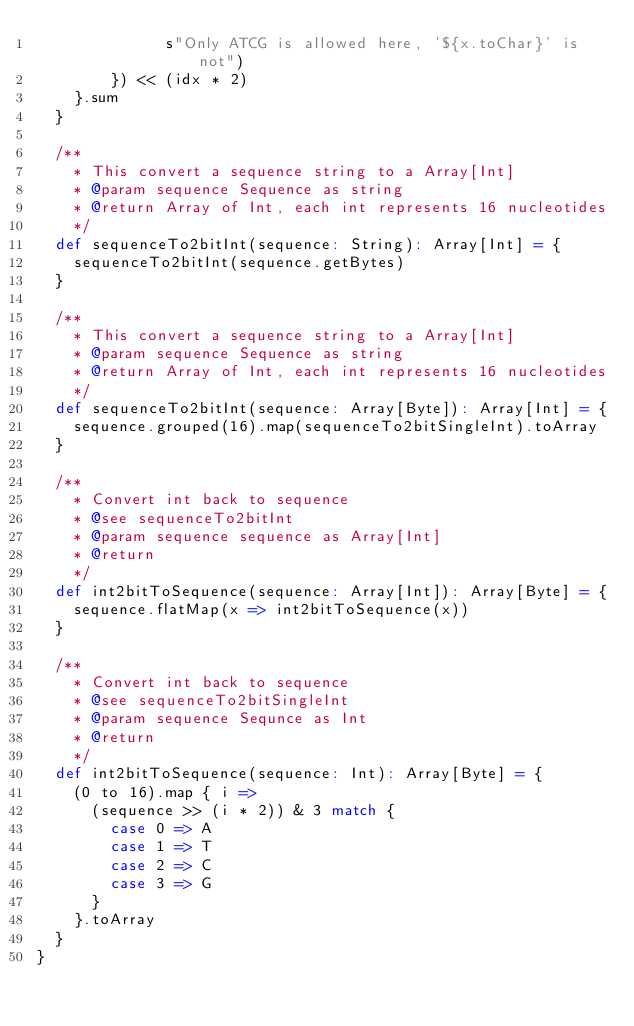Convert code to text. <code><loc_0><loc_0><loc_500><loc_500><_Scala_>              s"Only ATCG is allowed here, '${x.toChar}' is not")
        }) << (idx * 2)
    }.sum
  }

  /**
    * This convert a sequence string to a Array[Int]
    * @param sequence Sequence as string
    * @return Array of Int, each int represents 16 nucleotides
    */
  def sequenceTo2bitInt(sequence: String): Array[Int] = {
    sequenceTo2bitInt(sequence.getBytes)
  }

  /**
    * This convert a sequence string to a Array[Int]
    * @param sequence Sequence as string
    * @return Array of Int, each int represents 16 nucleotides
    */
  def sequenceTo2bitInt(sequence: Array[Byte]): Array[Int] = {
    sequence.grouped(16).map(sequenceTo2bitSingleInt).toArray
  }

  /**
    * Convert int back to sequence
    * @see sequenceTo2bitInt
    * @param sequence sequence as Array[Int]
    * @return
    */
  def int2bitToSequence(sequence: Array[Int]): Array[Byte] = {
    sequence.flatMap(x => int2bitToSequence(x))
  }

  /**
    * Convert int back to sequence
    * @see sequenceTo2bitSingleInt
    * @param sequence Sequnce as Int
    * @return
    */
  def int2bitToSequence(sequence: Int): Array[Byte] = {
    (0 to 16).map { i =>
      (sequence >> (i * 2)) & 3 match {
        case 0 => A
        case 1 => T
        case 2 => C
        case 3 => G
      }
    }.toArray
  }
}
</code> 